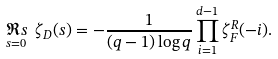<formula> <loc_0><loc_0><loc_500><loc_500>\underset { s = 0 } { \Re s } \ \zeta _ { D } ( s ) = - \frac { 1 } { ( q - 1 ) \log q } \prod _ { i = 1 } ^ { d - 1 } \zeta _ { F } ^ { R } ( - i ) .</formula> 